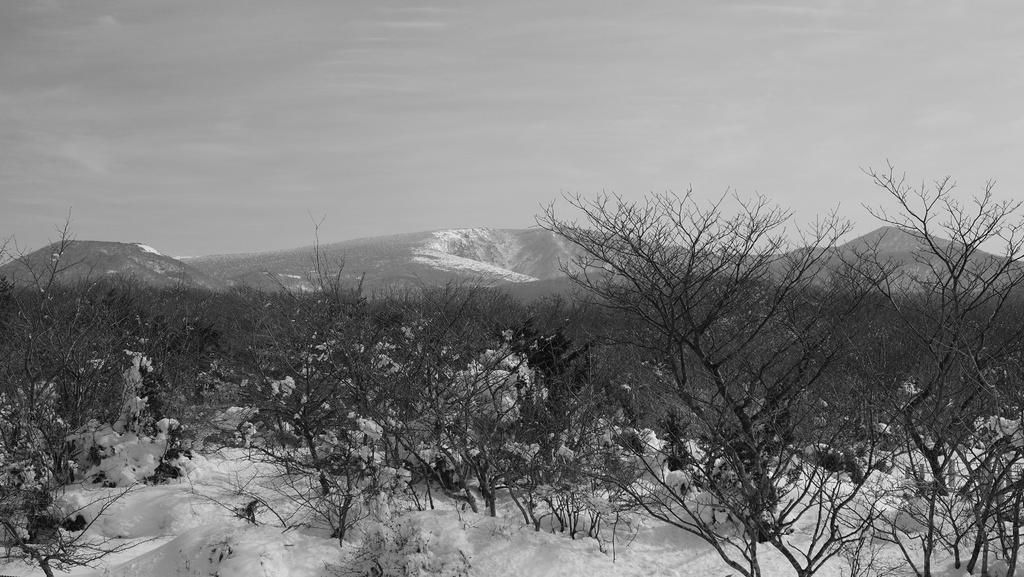Can you describe this image briefly? In this image I can see a dry trees,snow and mountains. The image is in black and white color. 